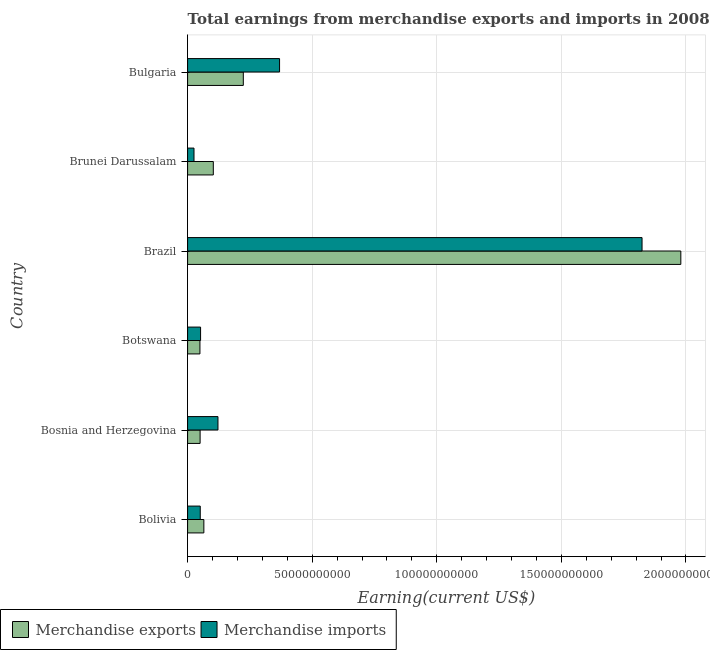Are the number of bars per tick equal to the number of legend labels?
Offer a very short reply. Yes. Are the number of bars on each tick of the Y-axis equal?
Make the answer very short. Yes. How many bars are there on the 4th tick from the top?
Provide a succinct answer. 2. What is the label of the 4th group of bars from the top?
Offer a terse response. Botswana. What is the earnings from merchandise imports in Bolivia?
Provide a succinct answer. 5.08e+09. Across all countries, what is the maximum earnings from merchandise imports?
Provide a succinct answer. 1.82e+11. Across all countries, what is the minimum earnings from merchandise imports?
Keep it short and to the point. 2.57e+09. In which country was the earnings from merchandise imports maximum?
Your response must be concise. Brazil. In which country was the earnings from merchandise imports minimum?
Provide a succinct answer. Brunei Darussalam. What is the total earnings from merchandise imports in the graph?
Provide a short and direct response. 2.44e+11. What is the difference between the earnings from merchandise exports in Bolivia and that in Bulgaria?
Offer a very short reply. -1.58e+1. What is the difference between the earnings from merchandise imports in Bosnia and Herzegovina and the earnings from merchandise exports in Brunei Darussalam?
Offer a very short reply. 1.87e+09. What is the average earnings from merchandise imports per country?
Keep it short and to the point. 4.07e+1. What is the difference between the earnings from merchandise imports and earnings from merchandise exports in Bulgaria?
Your response must be concise. 1.45e+1. In how many countries, is the earnings from merchandise imports greater than 150000000000 US$?
Your answer should be compact. 1. What is the ratio of the earnings from merchandise imports in Brazil to that in Bulgaria?
Keep it short and to the point. 4.94. What is the difference between the highest and the second highest earnings from merchandise imports?
Provide a succinct answer. 1.45e+11. What is the difference between the highest and the lowest earnings from merchandise imports?
Ensure brevity in your answer.  1.80e+11. Is the sum of the earnings from merchandise imports in Bosnia and Herzegovina and Botswana greater than the maximum earnings from merchandise exports across all countries?
Provide a succinct answer. No. Are the values on the major ticks of X-axis written in scientific E-notation?
Ensure brevity in your answer.  No. Does the graph contain grids?
Your answer should be compact. Yes. How many legend labels are there?
Make the answer very short. 2. What is the title of the graph?
Give a very brief answer. Total earnings from merchandise exports and imports in 2008. What is the label or title of the X-axis?
Give a very brief answer. Earning(current US$). What is the label or title of the Y-axis?
Offer a terse response. Country. What is the Earning(current US$) in Merchandise exports in Bolivia?
Offer a terse response. 6.53e+09. What is the Earning(current US$) in Merchandise imports in Bolivia?
Your response must be concise. 5.08e+09. What is the Earning(current US$) in Merchandise exports in Bosnia and Herzegovina?
Your answer should be compact. 5.02e+09. What is the Earning(current US$) of Merchandise imports in Bosnia and Herzegovina?
Your answer should be very brief. 1.22e+1. What is the Earning(current US$) in Merchandise exports in Botswana?
Ensure brevity in your answer.  4.95e+09. What is the Earning(current US$) of Merchandise imports in Botswana?
Ensure brevity in your answer.  5.21e+09. What is the Earning(current US$) of Merchandise exports in Brazil?
Provide a succinct answer. 1.98e+11. What is the Earning(current US$) in Merchandise imports in Brazil?
Give a very brief answer. 1.82e+11. What is the Earning(current US$) of Merchandise exports in Brunei Darussalam?
Ensure brevity in your answer.  1.03e+1. What is the Earning(current US$) in Merchandise imports in Brunei Darussalam?
Keep it short and to the point. 2.57e+09. What is the Earning(current US$) of Merchandise exports in Bulgaria?
Make the answer very short. 2.24e+1. What is the Earning(current US$) of Merchandise imports in Bulgaria?
Your answer should be very brief. 3.69e+1. Across all countries, what is the maximum Earning(current US$) of Merchandise exports?
Offer a terse response. 1.98e+11. Across all countries, what is the maximum Earning(current US$) of Merchandise imports?
Provide a succinct answer. 1.82e+11. Across all countries, what is the minimum Earning(current US$) of Merchandise exports?
Keep it short and to the point. 4.95e+09. Across all countries, what is the minimum Earning(current US$) in Merchandise imports?
Your answer should be very brief. 2.57e+09. What is the total Earning(current US$) in Merchandise exports in the graph?
Give a very brief answer. 2.47e+11. What is the total Earning(current US$) in Merchandise imports in the graph?
Make the answer very short. 2.44e+11. What is the difference between the Earning(current US$) in Merchandise exports in Bolivia and that in Bosnia and Herzegovina?
Offer a very short reply. 1.50e+09. What is the difference between the Earning(current US$) in Merchandise imports in Bolivia and that in Bosnia and Herzegovina?
Ensure brevity in your answer.  -7.11e+09. What is the difference between the Earning(current US$) in Merchandise exports in Bolivia and that in Botswana?
Offer a very short reply. 1.57e+09. What is the difference between the Earning(current US$) in Merchandise imports in Bolivia and that in Botswana?
Keep it short and to the point. -1.30e+08. What is the difference between the Earning(current US$) in Merchandise exports in Bolivia and that in Brazil?
Make the answer very short. -1.91e+11. What is the difference between the Earning(current US$) in Merchandise imports in Bolivia and that in Brazil?
Your response must be concise. -1.77e+11. What is the difference between the Earning(current US$) of Merchandise exports in Bolivia and that in Brunei Darussalam?
Provide a succinct answer. -3.79e+09. What is the difference between the Earning(current US$) of Merchandise imports in Bolivia and that in Brunei Darussalam?
Offer a very short reply. 2.51e+09. What is the difference between the Earning(current US$) of Merchandise exports in Bolivia and that in Bulgaria?
Provide a succinct answer. -1.58e+1. What is the difference between the Earning(current US$) of Merchandise imports in Bolivia and that in Bulgaria?
Your response must be concise. -3.18e+1. What is the difference between the Earning(current US$) in Merchandise exports in Bosnia and Herzegovina and that in Botswana?
Make the answer very short. 7.02e+07. What is the difference between the Earning(current US$) of Merchandise imports in Bosnia and Herzegovina and that in Botswana?
Your answer should be compact. 6.98e+09. What is the difference between the Earning(current US$) in Merchandise exports in Bosnia and Herzegovina and that in Brazil?
Your answer should be compact. -1.93e+11. What is the difference between the Earning(current US$) in Merchandise imports in Bosnia and Herzegovina and that in Brazil?
Provide a short and direct response. -1.70e+11. What is the difference between the Earning(current US$) of Merchandise exports in Bosnia and Herzegovina and that in Brunei Darussalam?
Offer a terse response. -5.30e+09. What is the difference between the Earning(current US$) in Merchandise imports in Bosnia and Herzegovina and that in Brunei Darussalam?
Make the answer very short. 9.62e+09. What is the difference between the Earning(current US$) of Merchandise exports in Bosnia and Herzegovina and that in Bulgaria?
Keep it short and to the point. -1.73e+1. What is the difference between the Earning(current US$) in Merchandise imports in Bosnia and Herzegovina and that in Bulgaria?
Offer a very short reply. -2.47e+1. What is the difference between the Earning(current US$) in Merchandise exports in Botswana and that in Brazil?
Offer a very short reply. -1.93e+11. What is the difference between the Earning(current US$) of Merchandise imports in Botswana and that in Brazil?
Provide a short and direct response. -1.77e+11. What is the difference between the Earning(current US$) of Merchandise exports in Botswana and that in Brunei Darussalam?
Keep it short and to the point. -5.37e+09. What is the difference between the Earning(current US$) in Merchandise imports in Botswana and that in Brunei Darussalam?
Your answer should be very brief. 2.64e+09. What is the difference between the Earning(current US$) of Merchandise exports in Botswana and that in Bulgaria?
Provide a succinct answer. -1.74e+1. What is the difference between the Earning(current US$) in Merchandise imports in Botswana and that in Bulgaria?
Your answer should be very brief. -3.17e+1. What is the difference between the Earning(current US$) of Merchandise exports in Brazil and that in Brunei Darussalam?
Offer a terse response. 1.88e+11. What is the difference between the Earning(current US$) in Merchandise imports in Brazil and that in Brunei Darussalam?
Offer a terse response. 1.80e+11. What is the difference between the Earning(current US$) of Merchandise exports in Brazil and that in Bulgaria?
Give a very brief answer. 1.76e+11. What is the difference between the Earning(current US$) of Merchandise imports in Brazil and that in Bulgaria?
Your answer should be compact. 1.45e+11. What is the difference between the Earning(current US$) of Merchandise exports in Brunei Darussalam and that in Bulgaria?
Give a very brief answer. -1.20e+1. What is the difference between the Earning(current US$) in Merchandise imports in Brunei Darussalam and that in Bulgaria?
Ensure brevity in your answer.  -3.43e+1. What is the difference between the Earning(current US$) of Merchandise exports in Bolivia and the Earning(current US$) of Merchandise imports in Bosnia and Herzegovina?
Your response must be concise. -5.66e+09. What is the difference between the Earning(current US$) in Merchandise exports in Bolivia and the Earning(current US$) in Merchandise imports in Botswana?
Your answer should be compact. 1.31e+09. What is the difference between the Earning(current US$) of Merchandise exports in Bolivia and the Earning(current US$) of Merchandise imports in Brazil?
Your answer should be compact. -1.76e+11. What is the difference between the Earning(current US$) in Merchandise exports in Bolivia and the Earning(current US$) in Merchandise imports in Brunei Darussalam?
Offer a terse response. 3.95e+09. What is the difference between the Earning(current US$) of Merchandise exports in Bolivia and the Earning(current US$) of Merchandise imports in Bulgaria?
Provide a short and direct response. -3.04e+1. What is the difference between the Earning(current US$) of Merchandise exports in Bosnia and Herzegovina and the Earning(current US$) of Merchandise imports in Botswana?
Provide a short and direct response. -1.90e+08. What is the difference between the Earning(current US$) of Merchandise exports in Bosnia and Herzegovina and the Earning(current US$) of Merchandise imports in Brazil?
Ensure brevity in your answer.  -1.77e+11. What is the difference between the Earning(current US$) in Merchandise exports in Bosnia and Herzegovina and the Earning(current US$) in Merchandise imports in Brunei Darussalam?
Offer a very short reply. 2.45e+09. What is the difference between the Earning(current US$) of Merchandise exports in Bosnia and Herzegovina and the Earning(current US$) of Merchandise imports in Bulgaria?
Your answer should be very brief. -3.19e+1. What is the difference between the Earning(current US$) in Merchandise exports in Botswana and the Earning(current US$) in Merchandise imports in Brazil?
Give a very brief answer. -1.77e+11. What is the difference between the Earning(current US$) in Merchandise exports in Botswana and the Earning(current US$) in Merchandise imports in Brunei Darussalam?
Your answer should be very brief. 2.38e+09. What is the difference between the Earning(current US$) in Merchandise exports in Botswana and the Earning(current US$) in Merchandise imports in Bulgaria?
Your response must be concise. -3.20e+1. What is the difference between the Earning(current US$) of Merchandise exports in Brazil and the Earning(current US$) of Merchandise imports in Brunei Darussalam?
Offer a terse response. 1.95e+11. What is the difference between the Earning(current US$) of Merchandise exports in Brazil and the Earning(current US$) of Merchandise imports in Bulgaria?
Your response must be concise. 1.61e+11. What is the difference between the Earning(current US$) of Merchandise exports in Brunei Darussalam and the Earning(current US$) of Merchandise imports in Bulgaria?
Ensure brevity in your answer.  -2.66e+1. What is the average Earning(current US$) of Merchandise exports per country?
Your answer should be very brief. 4.12e+1. What is the average Earning(current US$) in Merchandise imports per country?
Your answer should be very brief. 4.07e+1. What is the difference between the Earning(current US$) in Merchandise exports and Earning(current US$) in Merchandise imports in Bolivia?
Provide a succinct answer. 1.44e+09. What is the difference between the Earning(current US$) in Merchandise exports and Earning(current US$) in Merchandise imports in Bosnia and Herzegovina?
Keep it short and to the point. -7.17e+09. What is the difference between the Earning(current US$) of Merchandise exports and Earning(current US$) of Merchandise imports in Botswana?
Ensure brevity in your answer.  -2.60e+08. What is the difference between the Earning(current US$) of Merchandise exports and Earning(current US$) of Merchandise imports in Brazil?
Ensure brevity in your answer.  1.56e+1. What is the difference between the Earning(current US$) in Merchandise exports and Earning(current US$) in Merchandise imports in Brunei Darussalam?
Your answer should be very brief. 7.75e+09. What is the difference between the Earning(current US$) of Merchandise exports and Earning(current US$) of Merchandise imports in Bulgaria?
Your answer should be very brief. -1.45e+1. What is the ratio of the Earning(current US$) in Merchandise exports in Bolivia to that in Bosnia and Herzegovina?
Give a very brief answer. 1.3. What is the ratio of the Earning(current US$) in Merchandise imports in Bolivia to that in Bosnia and Herzegovina?
Your answer should be very brief. 0.42. What is the ratio of the Earning(current US$) in Merchandise exports in Bolivia to that in Botswana?
Provide a short and direct response. 1.32. What is the ratio of the Earning(current US$) of Merchandise imports in Bolivia to that in Botswana?
Your answer should be compact. 0.98. What is the ratio of the Earning(current US$) in Merchandise exports in Bolivia to that in Brazil?
Your answer should be compact. 0.03. What is the ratio of the Earning(current US$) of Merchandise imports in Bolivia to that in Brazil?
Provide a short and direct response. 0.03. What is the ratio of the Earning(current US$) of Merchandise exports in Bolivia to that in Brunei Darussalam?
Provide a succinct answer. 0.63. What is the ratio of the Earning(current US$) of Merchandise imports in Bolivia to that in Brunei Darussalam?
Your answer should be very brief. 1.98. What is the ratio of the Earning(current US$) of Merchandise exports in Bolivia to that in Bulgaria?
Provide a succinct answer. 0.29. What is the ratio of the Earning(current US$) in Merchandise imports in Bolivia to that in Bulgaria?
Your response must be concise. 0.14. What is the ratio of the Earning(current US$) in Merchandise exports in Bosnia and Herzegovina to that in Botswana?
Your response must be concise. 1.01. What is the ratio of the Earning(current US$) in Merchandise imports in Bosnia and Herzegovina to that in Botswana?
Ensure brevity in your answer.  2.34. What is the ratio of the Earning(current US$) in Merchandise exports in Bosnia and Herzegovina to that in Brazil?
Your answer should be very brief. 0.03. What is the ratio of the Earning(current US$) in Merchandise imports in Bosnia and Herzegovina to that in Brazil?
Your response must be concise. 0.07. What is the ratio of the Earning(current US$) of Merchandise exports in Bosnia and Herzegovina to that in Brunei Darussalam?
Make the answer very short. 0.49. What is the ratio of the Earning(current US$) in Merchandise imports in Bosnia and Herzegovina to that in Brunei Darussalam?
Offer a terse response. 4.74. What is the ratio of the Earning(current US$) in Merchandise exports in Bosnia and Herzegovina to that in Bulgaria?
Your response must be concise. 0.22. What is the ratio of the Earning(current US$) in Merchandise imports in Bosnia and Herzegovina to that in Bulgaria?
Keep it short and to the point. 0.33. What is the ratio of the Earning(current US$) of Merchandise exports in Botswana to that in Brazil?
Provide a short and direct response. 0.03. What is the ratio of the Earning(current US$) in Merchandise imports in Botswana to that in Brazil?
Your answer should be compact. 0.03. What is the ratio of the Earning(current US$) in Merchandise exports in Botswana to that in Brunei Darussalam?
Your answer should be compact. 0.48. What is the ratio of the Earning(current US$) of Merchandise imports in Botswana to that in Brunei Darussalam?
Give a very brief answer. 2.03. What is the ratio of the Earning(current US$) of Merchandise exports in Botswana to that in Bulgaria?
Provide a succinct answer. 0.22. What is the ratio of the Earning(current US$) in Merchandise imports in Botswana to that in Bulgaria?
Your answer should be compact. 0.14. What is the ratio of the Earning(current US$) of Merchandise exports in Brazil to that in Brunei Darussalam?
Your response must be concise. 19.18. What is the ratio of the Earning(current US$) of Merchandise imports in Brazil to that in Brunei Darussalam?
Ensure brevity in your answer.  70.91. What is the ratio of the Earning(current US$) of Merchandise exports in Brazil to that in Bulgaria?
Offer a very short reply. 8.85. What is the ratio of the Earning(current US$) of Merchandise imports in Brazil to that in Bulgaria?
Give a very brief answer. 4.94. What is the ratio of the Earning(current US$) in Merchandise exports in Brunei Darussalam to that in Bulgaria?
Make the answer very short. 0.46. What is the ratio of the Earning(current US$) of Merchandise imports in Brunei Darussalam to that in Bulgaria?
Keep it short and to the point. 0.07. What is the difference between the highest and the second highest Earning(current US$) in Merchandise exports?
Keep it short and to the point. 1.76e+11. What is the difference between the highest and the second highest Earning(current US$) in Merchandise imports?
Provide a succinct answer. 1.45e+11. What is the difference between the highest and the lowest Earning(current US$) in Merchandise exports?
Keep it short and to the point. 1.93e+11. What is the difference between the highest and the lowest Earning(current US$) of Merchandise imports?
Keep it short and to the point. 1.80e+11. 